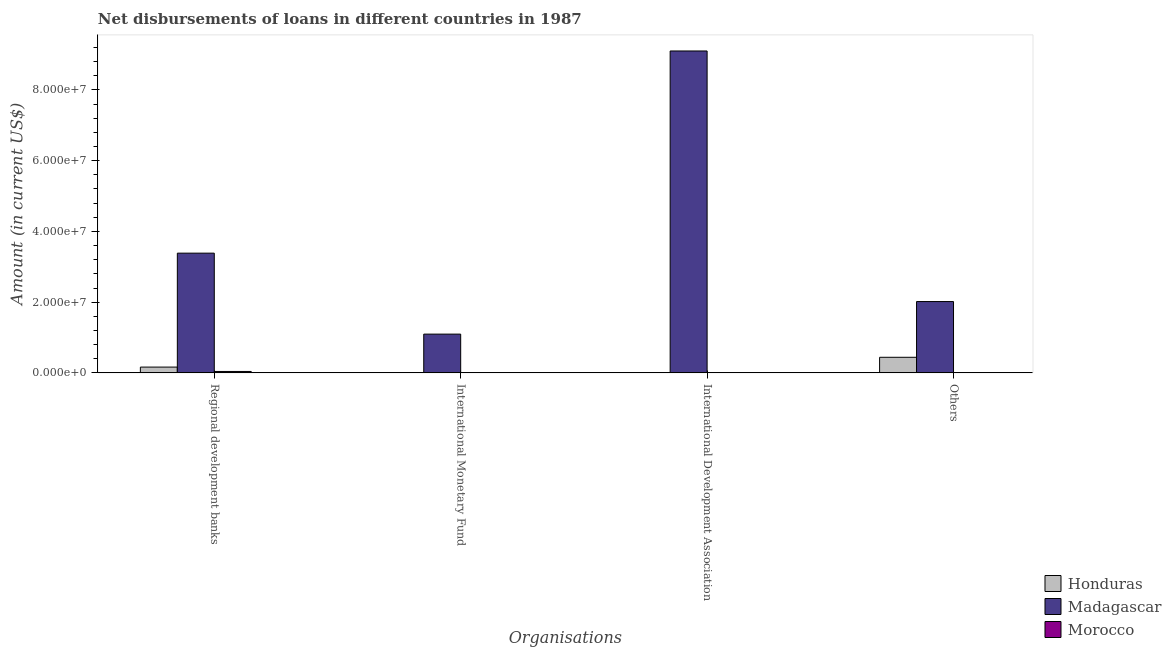How many different coloured bars are there?
Provide a succinct answer. 3. What is the label of the 1st group of bars from the left?
Provide a short and direct response. Regional development banks. Across all countries, what is the maximum amount of loan disimbursed by international development association?
Offer a very short reply. 9.10e+07. Across all countries, what is the minimum amount of loan disimbursed by other organisations?
Your answer should be very brief. 0. In which country was the amount of loan disimbursed by international monetary fund maximum?
Make the answer very short. Madagascar. What is the total amount of loan disimbursed by international monetary fund in the graph?
Your answer should be very brief. 1.10e+07. What is the difference between the amount of loan disimbursed by regional development banks in Madagascar and that in Honduras?
Your response must be concise. 3.22e+07. What is the difference between the amount of loan disimbursed by international monetary fund in Madagascar and the amount of loan disimbursed by regional development banks in Honduras?
Your response must be concise. 9.32e+06. What is the average amount of loan disimbursed by international monetary fund per country?
Provide a short and direct response. 3.65e+06. What is the difference between the amount of loan disimbursed by other organisations and amount of loan disimbursed by regional development banks in Madagascar?
Offer a very short reply. -1.37e+07. In how many countries, is the amount of loan disimbursed by regional development banks greater than 56000000 US$?
Your answer should be very brief. 0. What is the ratio of the amount of loan disimbursed by regional development banks in Honduras to that in Morocco?
Keep it short and to the point. 4.1. What is the difference between the highest and the second highest amount of loan disimbursed by regional development banks?
Make the answer very short. 3.22e+07. What is the difference between the highest and the lowest amount of loan disimbursed by international monetary fund?
Give a very brief answer. 1.10e+07. In how many countries, is the amount of loan disimbursed by international development association greater than the average amount of loan disimbursed by international development association taken over all countries?
Offer a very short reply. 1. Is it the case that in every country, the sum of the amount of loan disimbursed by regional development banks and amount of loan disimbursed by international monetary fund is greater than the amount of loan disimbursed by international development association?
Ensure brevity in your answer.  No. How many countries are there in the graph?
Offer a very short reply. 3. What is the difference between two consecutive major ticks on the Y-axis?
Your response must be concise. 2.00e+07. Are the values on the major ticks of Y-axis written in scientific E-notation?
Provide a succinct answer. Yes. Does the graph contain grids?
Keep it short and to the point. No. How many legend labels are there?
Provide a succinct answer. 3. What is the title of the graph?
Your response must be concise. Net disbursements of loans in different countries in 1987. Does "Ecuador" appear as one of the legend labels in the graph?
Your answer should be compact. No. What is the label or title of the X-axis?
Offer a very short reply. Organisations. What is the Amount (in current US$) in Honduras in Regional development banks?
Your answer should be compact. 1.64e+06. What is the Amount (in current US$) of Madagascar in Regional development banks?
Make the answer very short. 3.39e+07. What is the Amount (in current US$) in Morocco in Regional development banks?
Give a very brief answer. 3.99e+05. What is the Amount (in current US$) in Madagascar in International Monetary Fund?
Provide a short and direct response. 1.10e+07. What is the Amount (in current US$) in Honduras in International Development Association?
Provide a short and direct response. 0. What is the Amount (in current US$) in Madagascar in International Development Association?
Provide a short and direct response. 9.10e+07. What is the Amount (in current US$) of Honduras in Others?
Give a very brief answer. 4.41e+06. What is the Amount (in current US$) of Madagascar in Others?
Your answer should be compact. 2.02e+07. What is the Amount (in current US$) of Morocco in Others?
Offer a terse response. 0. Across all Organisations, what is the maximum Amount (in current US$) in Honduras?
Ensure brevity in your answer.  4.41e+06. Across all Organisations, what is the maximum Amount (in current US$) in Madagascar?
Your response must be concise. 9.10e+07. Across all Organisations, what is the maximum Amount (in current US$) in Morocco?
Your answer should be very brief. 3.99e+05. Across all Organisations, what is the minimum Amount (in current US$) of Honduras?
Provide a succinct answer. 0. Across all Organisations, what is the minimum Amount (in current US$) in Madagascar?
Offer a very short reply. 1.10e+07. What is the total Amount (in current US$) in Honduras in the graph?
Give a very brief answer. 6.04e+06. What is the total Amount (in current US$) of Madagascar in the graph?
Your response must be concise. 1.56e+08. What is the total Amount (in current US$) of Morocco in the graph?
Keep it short and to the point. 3.99e+05. What is the difference between the Amount (in current US$) of Madagascar in Regional development banks and that in International Monetary Fund?
Offer a terse response. 2.29e+07. What is the difference between the Amount (in current US$) in Madagascar in Regional development banks and that in International Development Association?
Give a very brief answer. -5.72e+07. What is the difference between the Amount (in current US$) of Honduras in Regional development banks and that in Others?
Provide a short and direct response. -2.77e+06. What is the difference between the Amount (in current US$) of Madagascar in Regional development banks and that in Others?
Offer a terse response. 1.37e+07. What is the difference between the Amount (in current US$) of Madagascar in International Monetary Fund and that in International Development Association?
Provide a succinct answer. -8.01e+07. What is the difference between the Amount (in current US$) in Madagascar in International Monetary Fund and that in Others?
Your answer should be very brief. -9.21e+06. What is the difference between the Amount (in current US$) in Madagascar in International Development Association and that in Others?
Make the answer very short. 7.09e+07. What is the difference between the Amount (in current US$) of Honduras in Regional development banks and the Amount (in current US$) of Madagascar in International Monetary Fund?
Give a very brief answer. -9.32e+06. What is the difference between the Amount (in current US$) in Honduras in Regional development banks and the Amount (in current US$) in Madagascar in International Development Association?
Your answer should be compact. -8.94e+07. What is the difference between the Amount (in current US$) of Honduras in Regional development banks and the Amount (in current US$) of Madagascar in Others?
Keep it short and to the point. -1.85e+07. What is the average Amount (in current US$) of Honduras per Organisations?
Give a very brief answer. 1.51e+06. What is the average Amount (in current US$) of Madagascar per Organisations?
Offer a terse response. 3.90e+07. What is the average Amount (in current US$) in Morocco per Organisations?
Make the answer very short. 9.98e+04. What is the difference between the Amount (in current US$) of Honduras and Amount (in current US$) of Madagascar in Regional development banks?
Make the answer very short. -3.22e+07. What is the difference between the Amount (in current US$) of Honduras and Amount (in current US$) of Morocco in Regional development banks?
Offer a very short reply. 1.24e+06. What is the difference between the Amount (in current US$) of Madagascar and Amount (in current US$) of Morocco in Regional development banks?
Offer a terse response. 3.35e+07. What is the difference between the Amount (in current US$) of Honduras and Amount (in current US$) of Madagascar in Others?
Provide a succinct answer. -1.58e+07. What is the ratio of the Amount (in current US$) in Madagascar in Regional development banks to that in International Monetary Fund?
Give a very brief answer. 3.09. What is the ratio of the Amount (in current US$) of Madagascar in Regional development banks to that in International Development Association?
Provide a succinct answer. 0.37. What is the ratio of the Amount (in current US$) in Honduras in Regional development banks to that in Others?
Give a very brief answer. 0.37. What is the ratio of the Amount (in current US$) in Madagascar in Regional development banks to that in Others?
Offer a very short reply. 1.68. What is the ratio of the Amount (in current US$) in Madagascar in International Monetary Fund to that in International Development Association?
Provide a succinct answer. 0.12. What is the ratio of the Amount (in current US$) in Madagascar in International Monetary Fund to that in Others?
Make the answer very short. 0.54. What is the ratio of the Amount (in current US$) in Madagascar in International Development Association to that in Others?
Give a very brief answer. 4.51. What is the difference between the highest and the second highest Amount (in current US$) of Madagascar?
Give a very brief answer. 5.72e+07. What is the difference between the highest and the lowest Amount (in current US$) of Honduras?
Give a very brief answer. 4.41e+06. What is the difference between the highest and the lowest Amount (in current US$) of Madagascar?
Offer a terse response. 8.01e+07. What is the difference between the highest and the lowest Amount (in current US$) of Morocco?
Your response must be concise. 3.99e+05. 